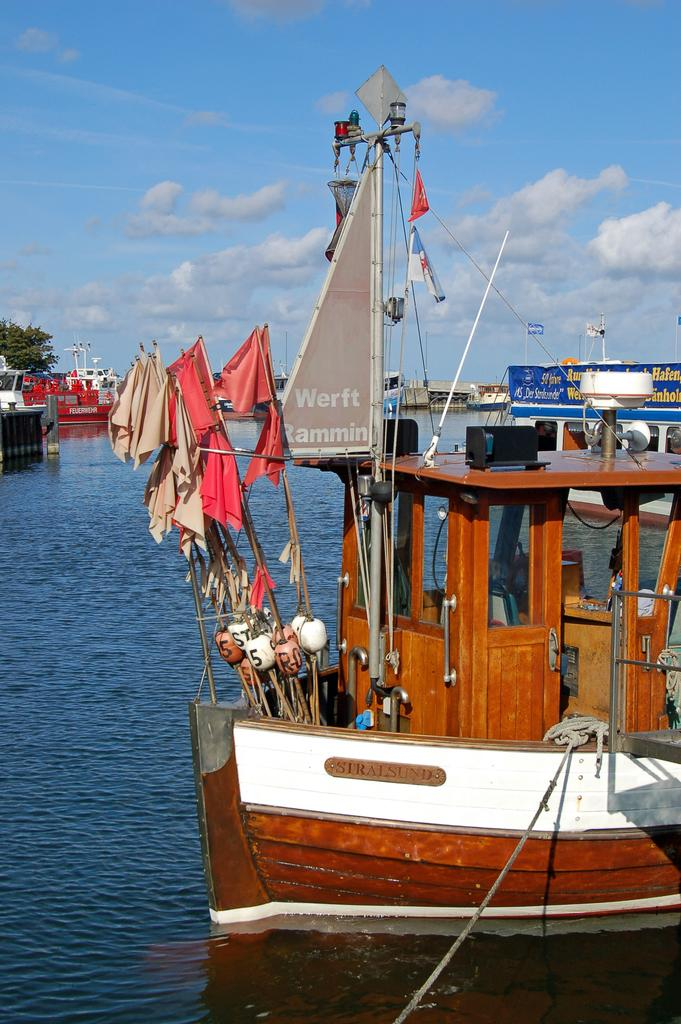Provide a one-sentence caption for the provided image. The sail on this ship reads Werft Rammin. 